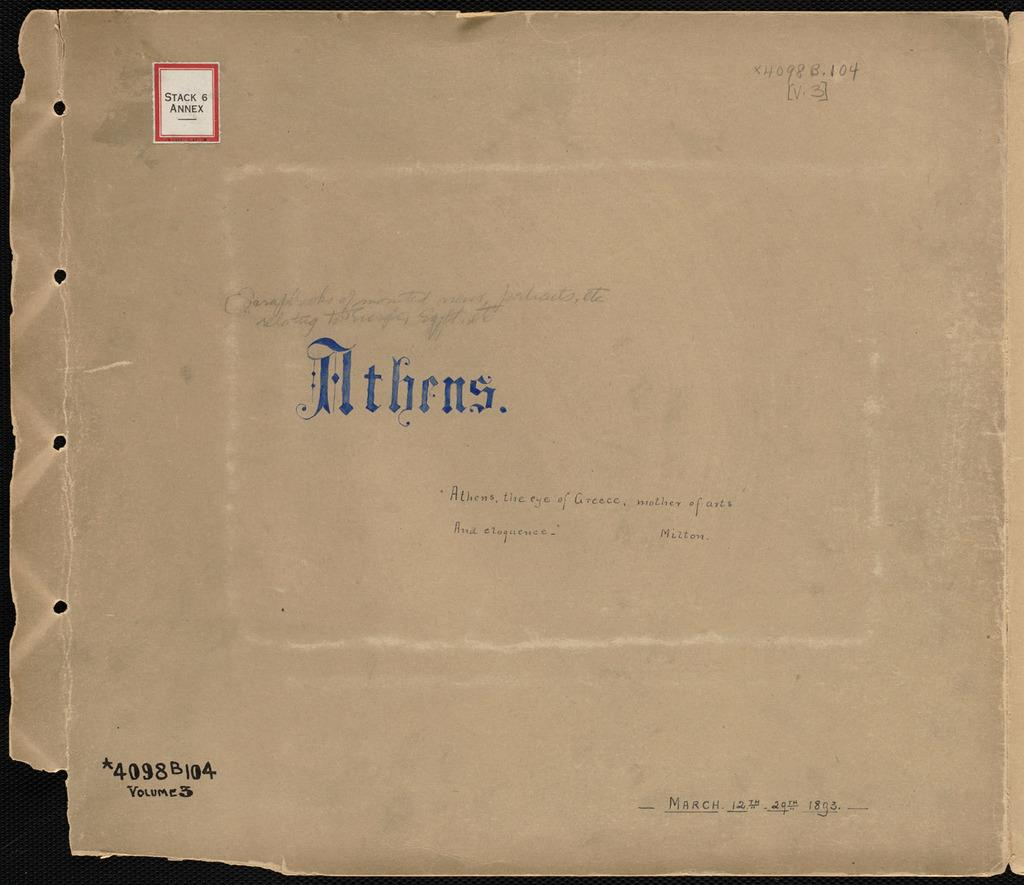Provide a one-sentence caption for the provided image. A very old brown cover that has the word Athens inscribed on it. 